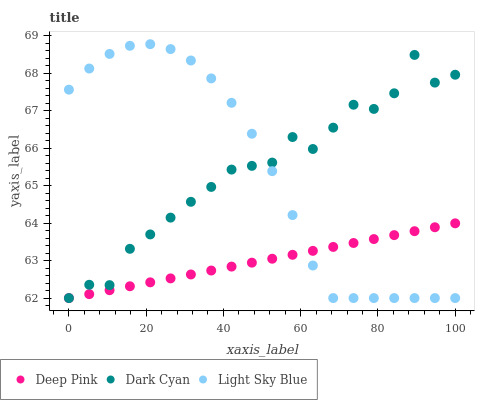Does Deep Pink have the minimum area under the curve?
Answer yes or no. Yes. Does Dark Cyan have the maximum area under the curve?
Answer yes or no. Yes. Does Light Sky Blue have the minimum area under the curve?
Answer yes or no. No. Does Light Sky Blue have the maximum area under the curve?
Answer yes or no. No. Is Deep Pink the smoothest?
Answer yes or no. Yes. Is Dark Cyan the roughest?
Answer yes or no. Yes. Is Light Sky Blue the smoothest?
Answer yes or no. No. Is Light Sky Blue the roughest?
Answer yes or no. No. Does Dark Cyan have the lowest value?
Answer yes or no. Yes. Does Light Sky Blue have the highest value?
Answer yes or no. Yes. Does Deep Pink have the highest value?
Answer yes or no. No. Does Deep Pink intersect Light Sky Blue?
Answer yes or no. Yes. Is Deep Pink less than Light Sky Blue?
Answer yes or no. No. Is Deep Pink greater than Light Sky Blue?
Answer yes or no. No. 